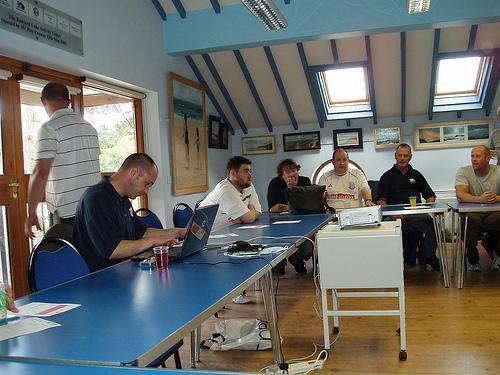How many people are in this room?
Give a very brief answer. 7. How many people are typing computer?
Give a very brief answer. 1. 